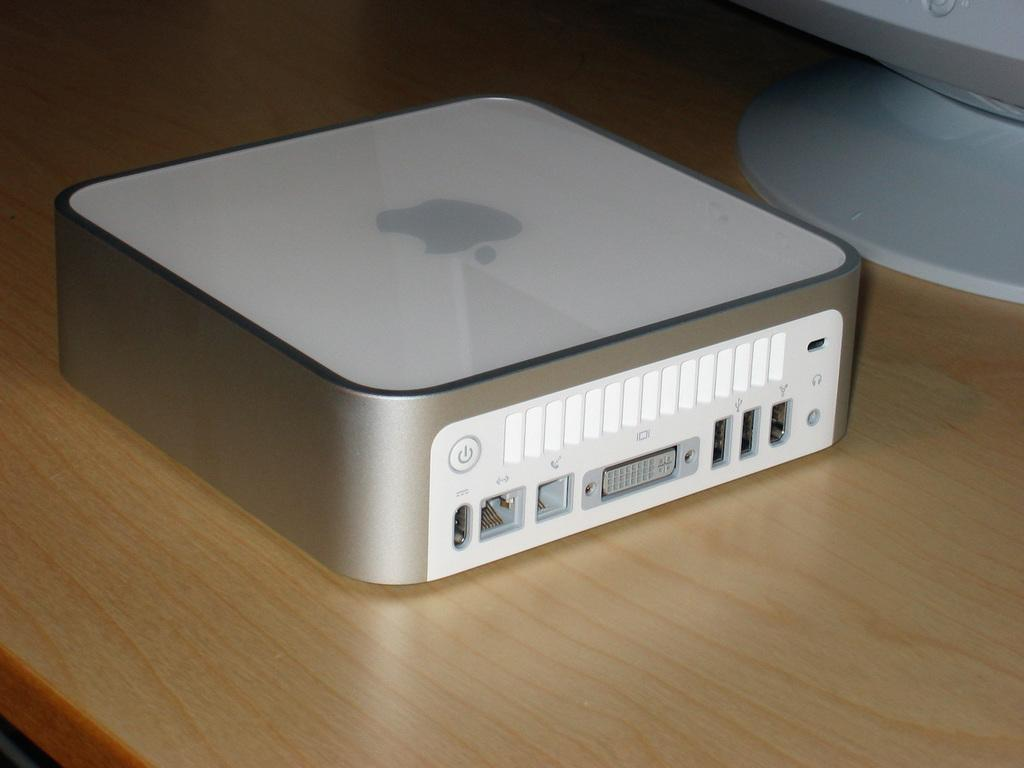What type of object is present on the table in the image? There is an electronic device on the table in the image. What is the electronic device's brand or operating system? The electronic device has an apple symbol, which suggests it is an Apple product. Can you describe the table where the electronic device is placed? The table is not described in the provided facts, so we cannot provide any details about it. What type of railway is visible in the image? There is no railway present in the image; it features an electronic device with an apple symbol on a table. How is the sister related to the electronic device in the image? There is no mention of a sister or any people in the image, so we cannot determine any relationships. 